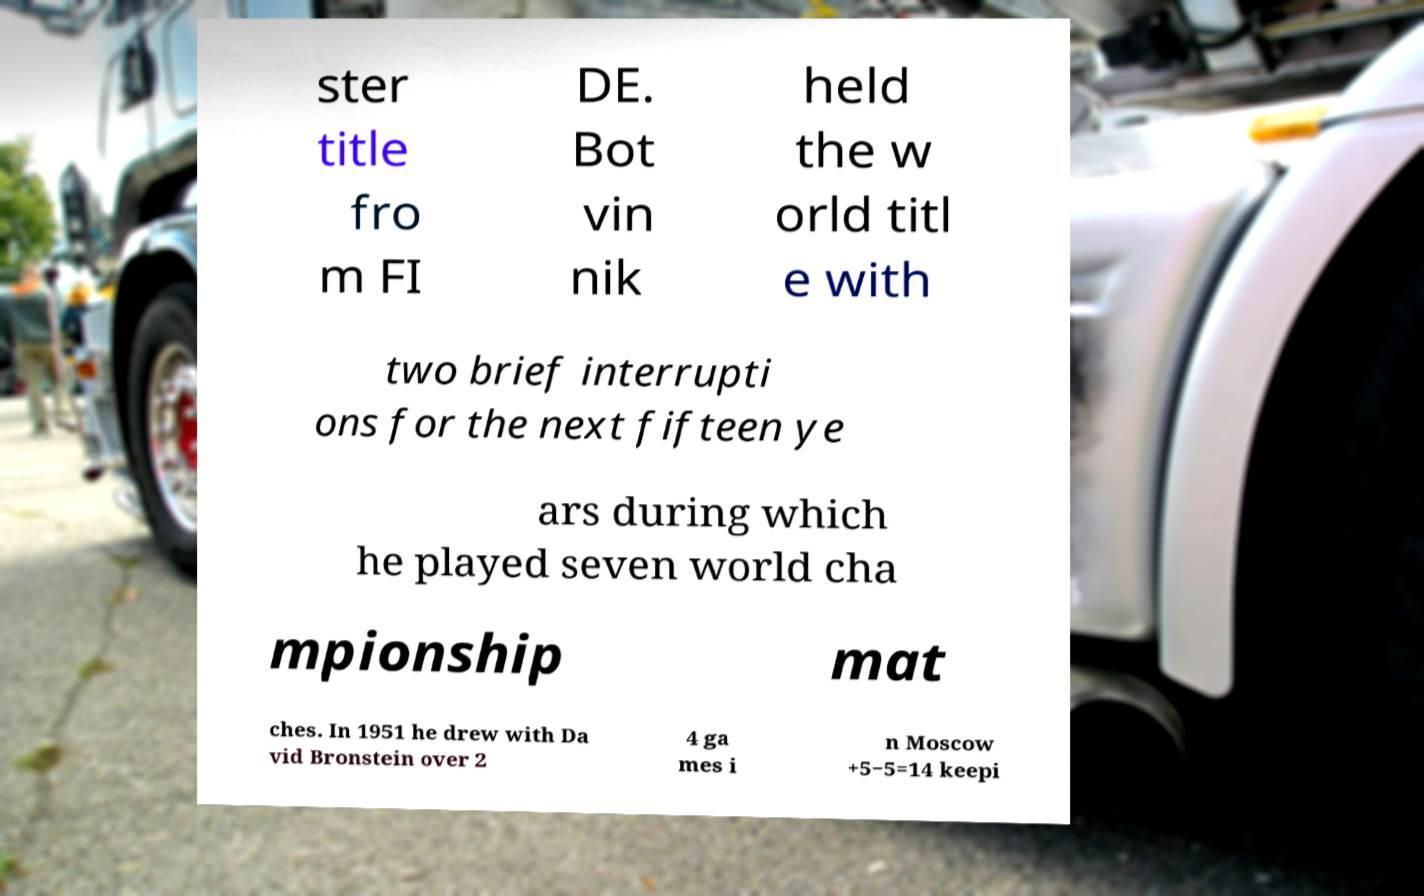For documentation purposes, I need the text within this image transcribed. Could you provide that? ster title fro m FI DE. Bot vin nik held the w orld titl e with two brief interrupti ons for the next fifteen ye ars during which he played seven world cha mpionship mat ches. In 1951 he drew with Da vid Bronstein over 2 4 ga mes i n Moscow +5−5=14 keepi 